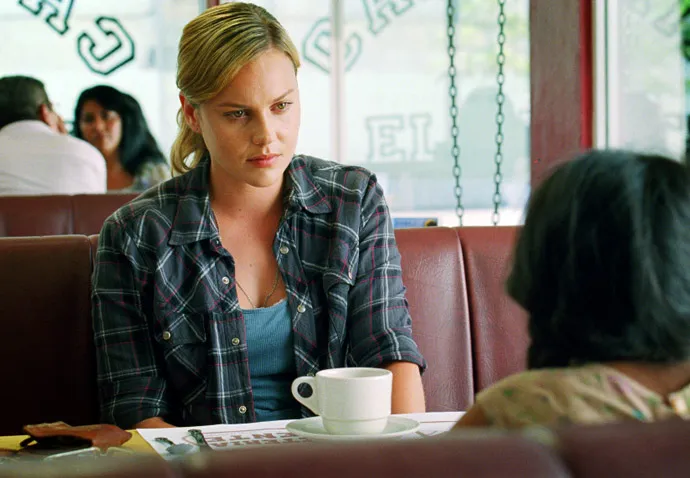Describe the emotions conveyed in this scene. The image portrays a somber scene with the woman appearing to be deep in contemplation or engagement in a serious conversation. Her slightly furrowed brow and intent gaze suggest she might be discussing something important or troubling. The atmosphere in the diner, combined with her expression, conveys a mood of introspective seriousness. What could be the topic of their conversation? Given the expressions and the setting, it's plausible that the topic of conversation could be of a personal nature, perhaps discussing a relationship issue, a significant life decision, or comforting a friend in distress. The woman's intense focus on the other person hints at a deep and meaningful dialogue taking place. 